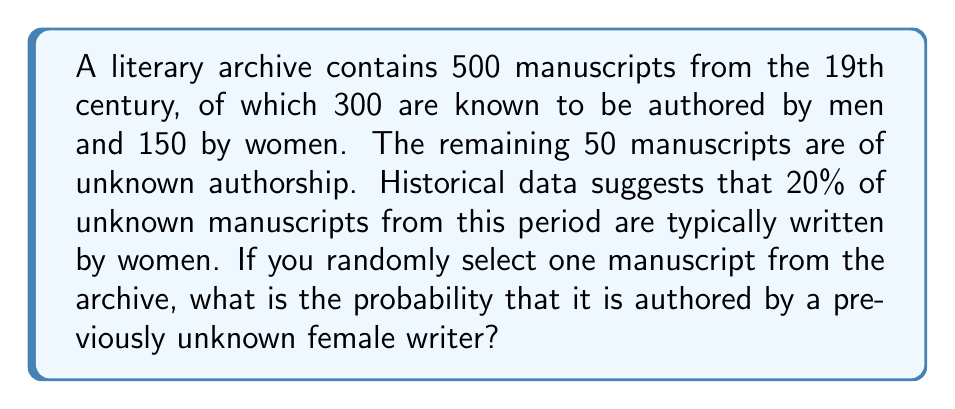Solve this math problem. Let's approach this step-by-step:

1) First, we need to calculate the total number of manuscripts authored by women:
   - Known female authors: 150
   - Unknown female authors: 20% of 50 = $0.20 \times 50 = 10$
   - Total female-authored manuscripts: $150 + 10 = 160$

2) Now, we need to identify how many of these are by previously unknown female authors:
   - This is simply the number of unknown female authors: 10

3) The probability is calculated by dividing the number of favorable outcomes by the total number of possible outcomes:

   $$P(\text{unknown female author}) = \frac{\text{number of manuscripts by unknown female authors}}{\text{total number of manuscripts}}$$

4) Substituting the values:

   $$P(\text{unknown female author}) = \frac{10}{500} = \frac{1}{50} = 0.02$$

5) Therefore, the probability of selecting a manuscript by a previously unknown female author is 0.02 or 2%.
Answer: $\frac{1}{50}$ or 0.02 or 2% 